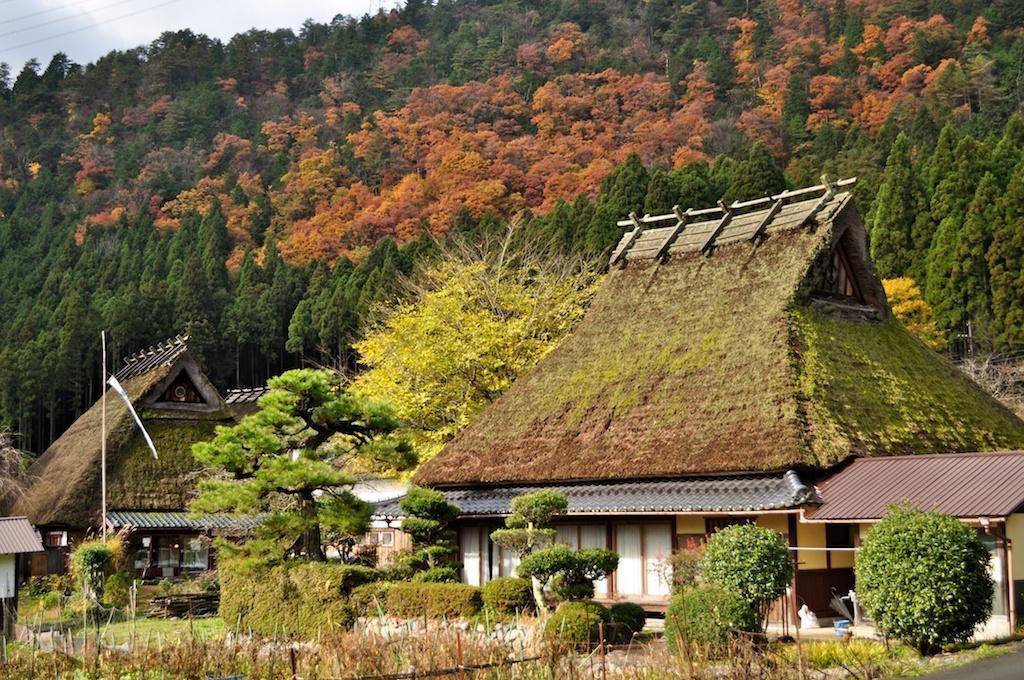Can you describe this image briefly? In this image we can see a few houses, there are some plants, trees, stones and poles, also we can see the sky. 